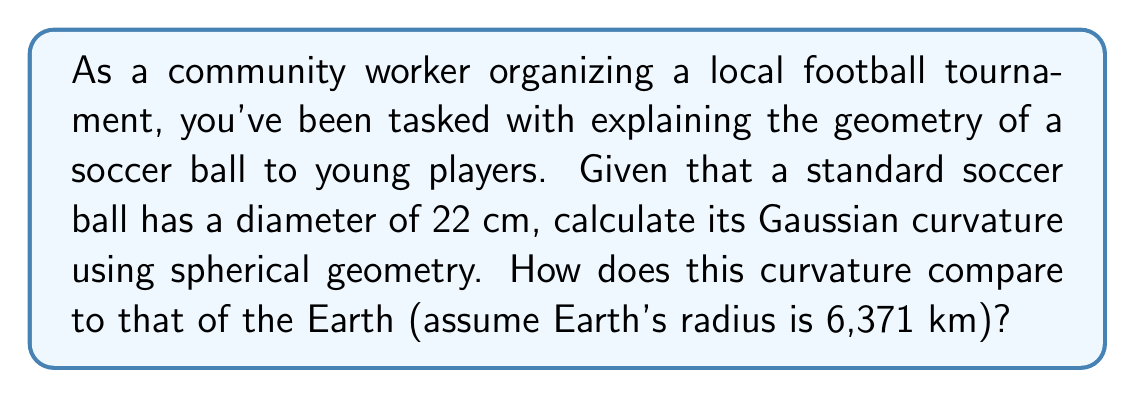Give your solution to this math problem. Let's approach this step-by-step:

1) In spherical geometry, the Gaussian curvature $K$ of a sphere is given by:

   $$K = \frac{1}{R^2}$$

   where $R$ is the radius of the sphere.

2) For the soccer ball:
   - Diameter = 22 cm
   - Radius = 11 cm = 0.11 m

3) Calculate the curvature of the soccer ball:

   $$K_{ball} = \frac{1}{(0.11 \text{ m})^2} = 82.64 \text{ m}^{-2}$$

4) For Earth:
   - Radius = 6,371 km = 6,371,000 m

5) Calculate the curvature of Earth:

   $$K_{Earth} = \frac{1}{(6,371,000 \text{ m})^2} = 2.46 \times 10^{-14} \text{ m}^{-2}$$

6) To compare, we can divide the curvature of the soccer ball by the curvature of Earth:

   $$\frac{K_{ball}}{K_{Earth}} = \frac{82.64}{2.46 \times 10^{-14}} \approx 3.36 \times 10^{15}$$

This means the soccer ball's curvature is about 3.36 trillion times greater than Earth's.
Answer: $K_{ball} = 82.64 \text{ m}^{-2}$; $3.36 \times 10^{15}$ times Earth's curvature 